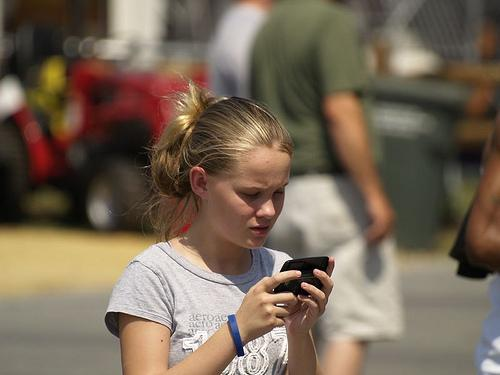What phone feature is she using? text 